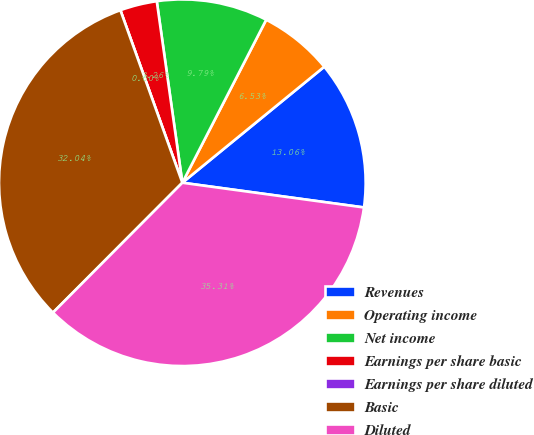Convert chart to OTSL. <chart><loc_0><loc_0><loc_500><loc_500><pie_chart><fcel>Revenues<fcel>Operating income<fcel>Net income<fcel>Earnings per share basic<fcel>Earnings per share diluted<fcel>Basic<fcel>Diluted<nl><fcel>13.06%<fcel>6.53%<fcel>9.79%<fcel>3.26%<fcel>0.0%<fcel>32.04%<fcel>35.31%<nl></chart> 